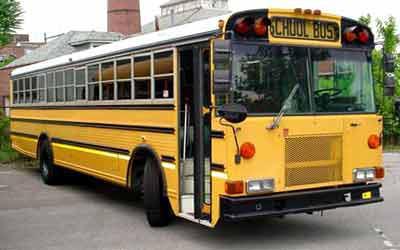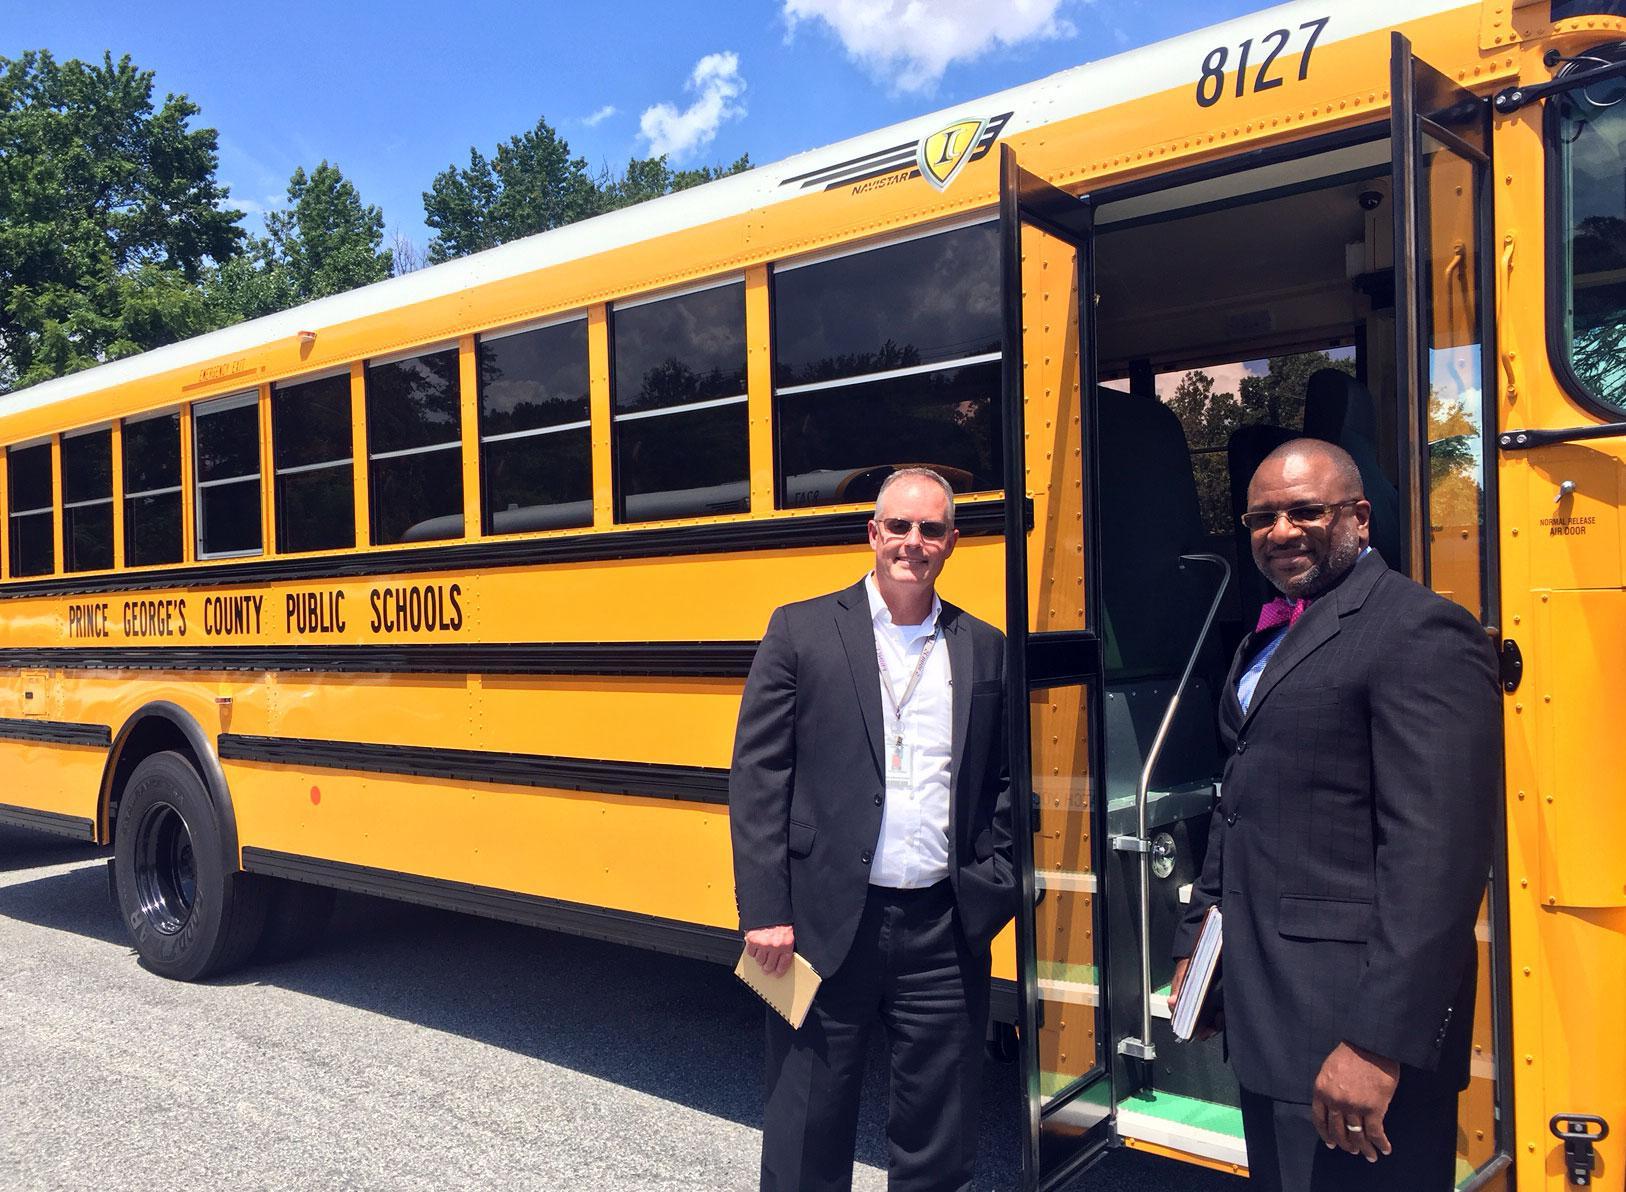The first image is the image on the left, the second image is the image on the right. Assess this claim about the two images: "At least 2 people are standing on the ground next to the school bus.". Correct or not? Answer yes or no. Yes. The first image is the image on the left, the second image is the image on the right. For the images displayed, is the sentence "People stand outside the bus in the image on the right." factually correct? Answer yes or no. Yes. 